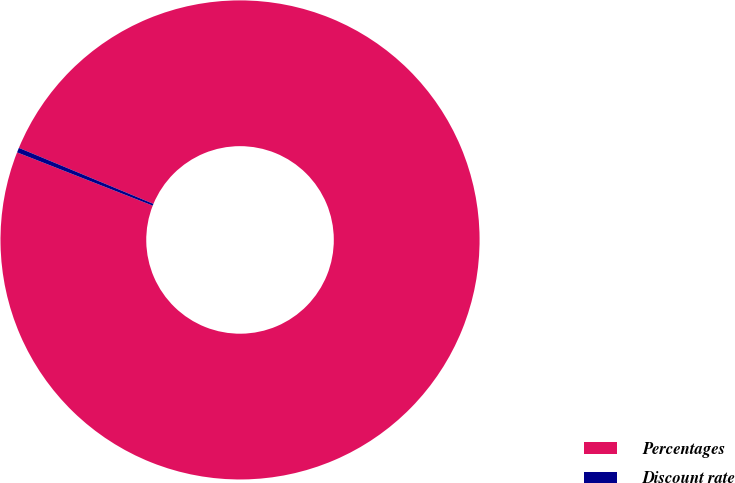Convert chart to OTSL. <chart><loc_0><loc_0><loc_500><loc_500><pie_chart><fcel>Percentages<fcel>Discount rate<nl><fcel>99.68%<fcel>0.32%<nl></chart> 